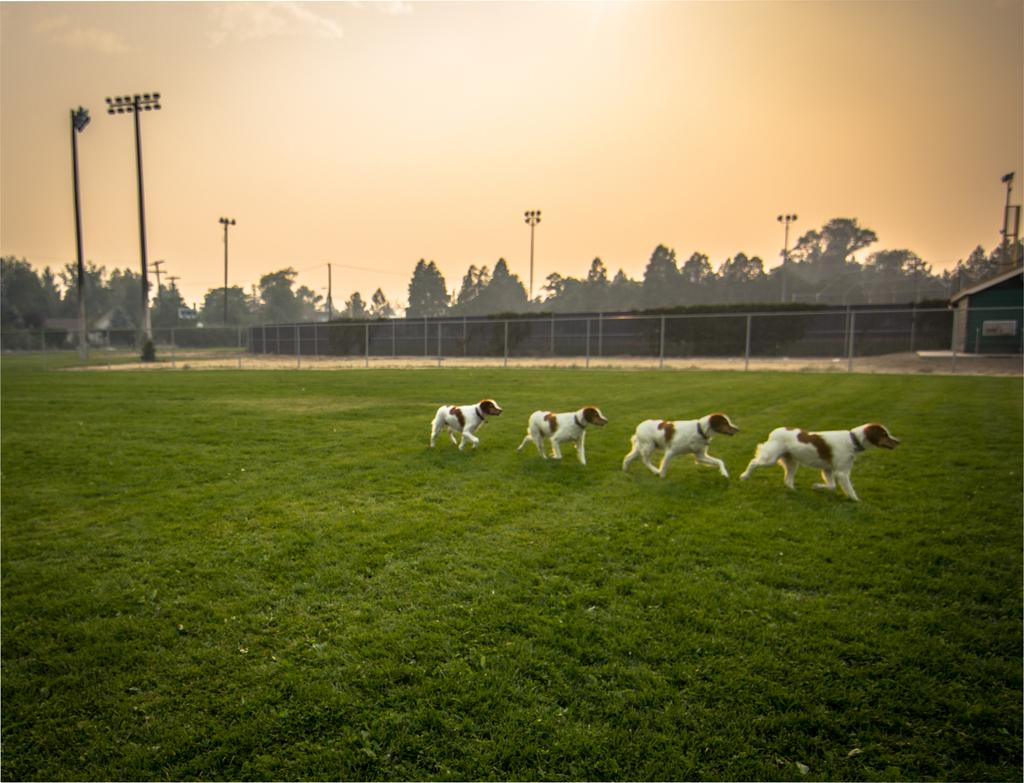How many dogs are present in the image? There are four dogs in the image. What are the dogs doing in the image? The dogs are walking on the grass. What other objects can be seen in the image? There are poles and trees in the image. Where is the house located in the image? The house is on the left side of the image. What type of calculator is being used by the dogs in the image? There is no calculator present in the image; it features four dogs walking on the grass. What plot of land are the dogs walking on in the image? The image does not provide information about the specific plot of land; it only shows the dogs walking on grass. 